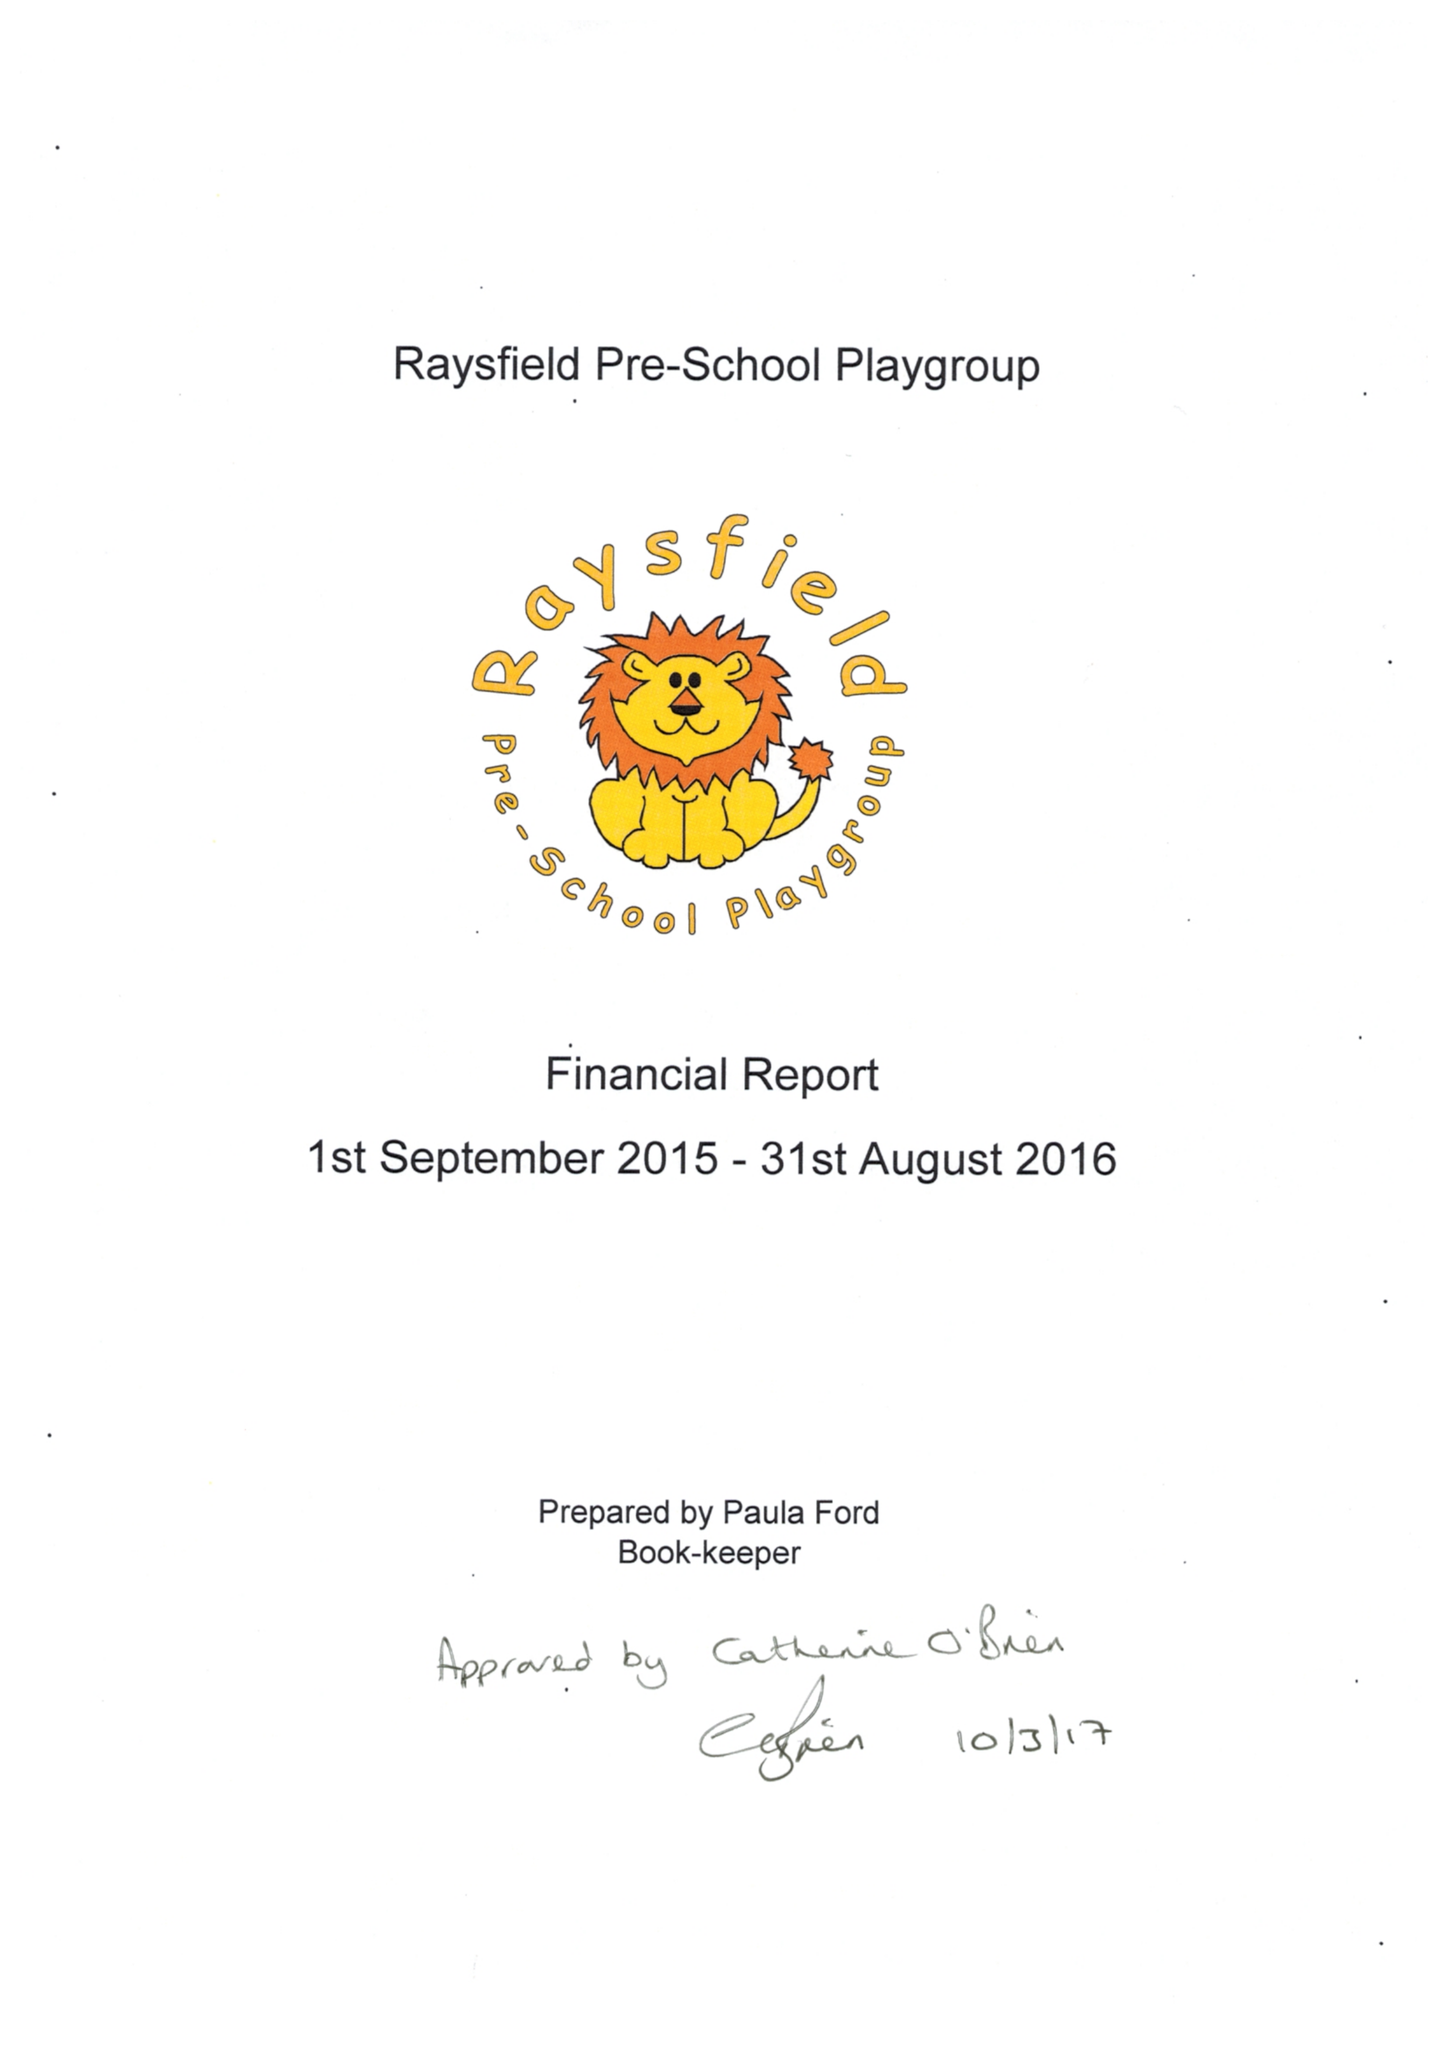What is the value for the income_annually_in_british_pounds?
Answer the question using a single word or phrase. 105984.00 